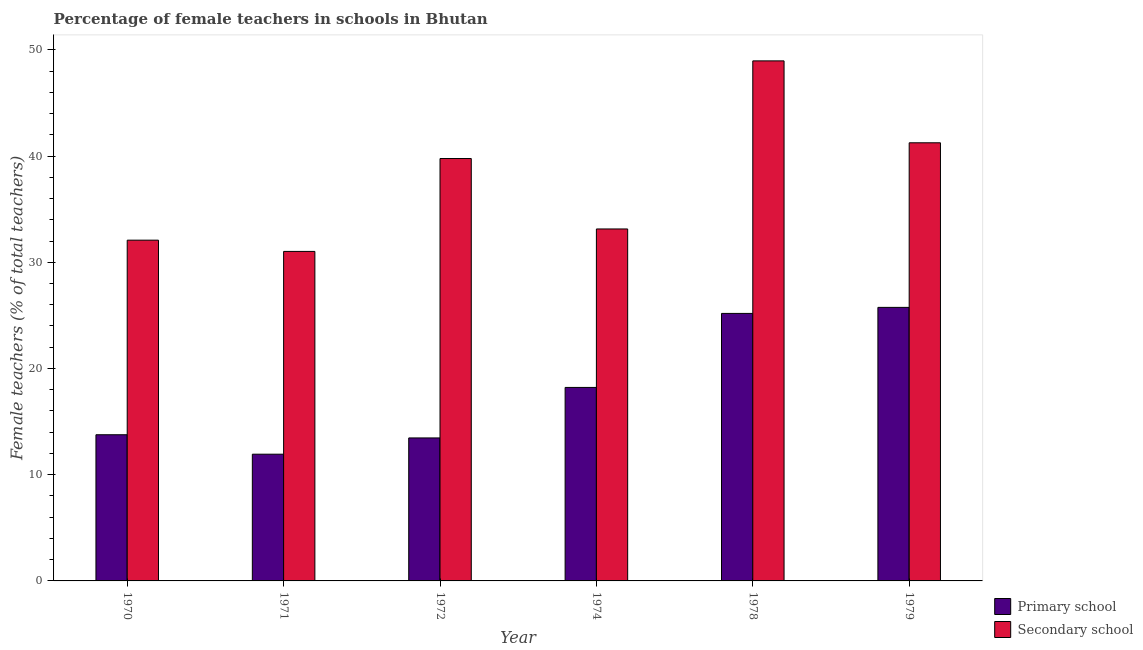How many groups of bars are there?
Ensure brevity in your answer.  6. Are the number of bars per tick equal to the number of legend labels?
Make the answer very short. Yes. Are the number of bars on each tick of the X-axis equal?
Keep it short and to the point. Yes. How many bars are there on the 2nd tick from the right?
Your answer should be compact. 2. What is the label of the 5th group of bars from the left?
Provide a short and direct response. 1978. In how many cases, is the number of bars for a given year not equal to the number of legend labels?
Provide a short and direct response. 0. What is the percentage of female teachers in primary schools in 1974?
Your answer should be very brief. 18.22. Across all years, what is the maximum percentage of female teachers in primary schools?
Your answer should be compact. 25.75. Across all years, what is the minimum percentage of female teachers in primary schools?
Keep it short and to the point. 11.93. In which year was the percentage of female teachers in primary schools maximum?
Your response must be concise. 1979. In which year was the percentage of female teachers in primary schools minimum?
Your answer should be compact. 1971. What is the total percentage of female teachers in primary schools in the graph?
Make the answer very short. 108.31. What is the difference between the percentage of female teachers in secondary schools in 1971 and that in 1978?
Give a very brief answer. -17.94. What is the difference between the percentage of female teachers in primary schools in 1972 and the percentage of female teachers in secondary schools in 1979?
Make the answer very short. -12.29. What is the average percentage of female teachers in primary schools per year?
Provide a succinct answer. 18.05. In the year 1972, what is the difference between the percentage of female teachers in primary schools and percentage of female teachers in secondary schools?
Provide a short and direct response. 0. In how many years, is the percentage of female teachers in secondary schools greater than 44 %?
Offer a terse response. 1. What is the ratio of the percentage of female teachers in primary schools in 1970 to that in 1979?
Your answer should be compact. 0.53. Is the difference between the percentage of female teachers in secondary schools in 1970 and 1972 greater than the difference between the percentage of female teachers in primary schools in 1970 and 1972?
Make the answer very short. No. What is the difference between the highest and the second highest percentage of female teachers in secondary schools?
Offer a very short reply. 7.71. What is the difference between the highest and the lowest percentage of female teachers in secondary schools?
Your answer should be very brief. 17.94. In how many years, is the percentage of female teachers in primary schools greater than the average percentage of female teachers in primary schools taken over all years?
Offer a terse response. 3. What does the 2nd bar from the left in 1978 represents?
Your answer should be compact. Secondary school. What does the 1st bar from the right in 1979 represents?
Offer a very short reply. Secondary school. What is the difference between two consecutive major ticks on the Y-axis?
Provide a succinct answer. 10. Are the values on the major ticks of Y-axis written in scientific E-notation?
Offer a terse response. No. Does the graph contain grids?
Ensure brevity in your answer.  No. What is the title of the graph?
Your response must be concise. Percentage of female teachers in schools in Bhutan. Does "Forest" appear as one of the legend labels in the graph?
Make the answer very short. No. What is the label or title of the X-axis?
Provide a short and direct response. Year. What is the label or title of the Y-axis?
Ensure brevity in your answer.  Female teachers (% of total teachers). What is the Female teachers (% of total teachers) of Primary school in 1970?
Give a very brief answer. 13.76. What is the Female teachers (% of total teachers) in Secondary school in 1970?
Keep it short and to the point. 32.08. What is the Female teachers (% of total teachers) in Primary school in 1971?
Offer a terse response. 11.93. What is the Female teachers (% of total teachers) in Secondary school in 1971?
Your answer should be compact. 31.02. What is the Female teachers (% of total teachers) of Primary school in 1972?
Your response must be concise. 13.46. What is the Female teachers (% of total teachers) of Secondary school in 1972?
Provide a short and direct response. 39.77. What is the Female teachers (% of total teachers) of Primary school in 1974?
Your answer should be very brief. 18.22. What is the Female teachers (% of total teachers) in Secondary school in 1974?
Offer a terse response. 33.14. What is the Female teachers (% of total teachers) in Primary school in 1978?
Your answer should be very brief. 25.18. What is the Female teachers (% of total teachers) in Secondary school in 1978?
Your answer should be very brief. 48.96. What is the Female teachers (% of total teachers) in Primary school in 1979?
Your response must be concise. 25.75. What is the Female teachers (% of total teachers) in Secondary school in 1979?
Provide a succinct answer. 41.25. Across all years, what is the maximum Female teachers (% of total teachers) of Primary school?
Provide a succinct answer. 25.75. Across all years, what is the maximum Female teachers (% of total teachers) of Secondary school?
Your answer should be compact. 48.96. Across all years, what is the minimum Female teachers (% of total teachers) in Primary school?
Ensure brevity in your answer.  11.93. Across all years, what is the minimum Female teachers (% of total teachers) in Secondary school?
Keep it short and to the point. 31.02. What is the total Female teachers (% of total teachers) of Primary school in the graph?
Your response must be concise. 108.31. What is the total Female teachers (% of total teachers) in Secondary school in the graph?
Your answer should be very brief. 226.21. What is the difference between the Female teachers (% of total teachers) in Primary school in 1970 and that in 1971?
Provide a succinct answer. 1.83. What is the difference between the Female teachers (% of total teachers) of Secondary school in 1970 and that in 1971?
Your response must be concise. 1.06. What is the difference between the Female teachers (% of total teachers) of Primary school in 1970 and that in 1972?
Your answer should be very brief. 0.3. What is the difference between the Female teachers (% of total teachers) in Secondary school in 1970 and that in 1972?
Your response must be concise. -7.69. What is the difference between the Female teachers (% of total teachers) of Primary school in 1970 and that in 1974?
Provide a succinct answer. -4.45. What is the difference between the Female teachers (% of total teachers) of Secondary school in 1970 and that in 1974?
Keep it short and to the point. -1.05. What is the difference between the Female teachers (% of total teachers) of Primary school in 1970 and that in 1978?
Make the answer very short. -11.42. What is the difference between the Female teachers (% of total teachers) of Secondary school in 1970 and that in 1978?
Give a very brief answer. -16.88. What is the difference between the Female teachers (% of total teachers) in Primary school in 1970 and that in 1979?
Your response must be concise. -11.99. What is the difference between the Female teachers (% of total teachers) in Secondary school in 1970 and that in 1979?
Give a very brief answer. -9.17. What is the difference between the Female teachers (% of total teachers) of Primary school in 1971 and that in 1972?
Offer a very short reply. -1.53. What is the difference between the Female teachers (% of total teachers) of Secondary school in 1971 and that in 1972?
Keep it short and to the point. -8.75. What is the difference between the Female teachers (% of total teachers) of Primary school in 1971 and that in 1974?
Your response must be concise. -6.29. What is the difference between the Female teachers (% of total teachers) of Secondary school in 1971 and that in 1974?
Your response must be concise. -2.12. What is the difference between the Female teachers (% of total teachers) in Primary school in 1971 and that in 1978?
Provide a short and direct response. -13.25. What is the difference between the Female teachers (% of total teachers) of Secondary school in 1971 and that in 1978?
Provide a short and direct response. -17.94. What is the difference between the Female teachers (% of total teachers) in Primary school in 1971 and that in 1979?
Your answer should be very brief. -13.82. What is the difference between the Female teachers (% of total teachers) of Secondary school in 1971 and that in 1979?
Give a very brief answer. -10.23. What is the difference between the Female teachers (% of total teachers) of Primary school in 1972 and that in 1974?
Ensure brevity in your answer.  -4.75. What is the difference between the Female teachers (% of total teachers) in Secondary school in 1972 and that in 1974?
Make the answer very short. 6.63. What is the difference between the Female teachers (% of total teachers) in Primary school in 1972 and that in 1978?
Offer a terse response. -11.72. What is the difference between the Female teachers (% of total teachers) in Secondary school in 1972 and that in 1978?
Give a very brief answer. -9.19. What is the difference between the Female teachers (% of total teachers) in Primary school in 1972 and that in 1979?
Ensure brevity in your answer.  -12.29. What is the difference between the Female teachers (% of total teachers) in Secondary school in 1972 and that in 1979?
Your response must be concise. -1.48. What is the difference between the Female teachers (% of total teachers) in Primary school in 1974 and that in 1978?
Give a very brief answer. -6.97. What is the difference between the Female teachers (% of total teachers) of Secondary school in 1974 and that in 1978?
Your answer should be compact. -15.82. What is the difference between the Female teachers (% of total teachers) of Primary school in 1974 and that in 1979?
Offer a very short reply. -7.54. What is the difference between the Female teachers (% of total teachers) of Secondary school in 1974 and that in 1979?
Make the answer very short. -8.11. What is the difference between the Female teachers (% of total teachers) in Primary school in 1978 and that in 1979?
Provide a short and direct response. -0.57. What is the difference between the Female teachers (% of total teachers) of Secondary school in 1978 and that in 1979?
Offer a very short reply. 7.71. What is the difference between the Female teachers (% of total teachers) of Primary school in 1970 and the Female teachers (% of total teachers) of Secondary school in 1971?
Offer a very short reply. -17.26. What is the difference between the Female teachers (% of total teachers) in Primary school in 1970 and the Female teachers (% of total teachers) in Secondary school in 1972?
Provide a short and direct response. -26.01. What is the difference between the Female teachers (% of total teachers) in Primary school in 1970 and the Female teachers (% of total teachers) in Secondary school in 1974?
Provide a short and direct response. -19.37. What is the difference between the Female teachers (% of total teachers) in Primary school in 1970 and the Female teachers (% of total teachers) in Secondary school in 1978?
Your answer should be very brief. -35.2. What is the difference between the Female teachers (% of total teachers) in Primary school in 1970 and the Female teachers (% of total teachers) in Secondary school in 1979?
Offer a very short reply. -27.49. What is the difference between the Female teachers (% of total teachers) of Primary school in 1971 and the Female teachers (% of total teachers) of Secondary school in 1972?
Your response must be concise. -27.84. What is the difference between the Female teachers (% of total teachers) of Primary school in 1971 and the Female teachers (% of total teachers) of Secondary school in 1974?
Keep it short and to the point. -21.21. What is the difference between the Female teachers (% of total teachers) in Primary school in 1971 and the Female teachers (% of total teachers) in Secondary school in 1978?
Offer a very short reply. -37.03. What is the difference between the Female teachers (% of total teachers) in Primary school in 1971 and the Female teachers (% of total teachers) in Secondary school in 1979?
Ensure brevity in your answer.  -29.32. What is the difference between the Female teachers (% of total teachers) of Primary school in 1972 and the Female teachers (% of total teachers) of Secondary school in 1974?
Your answer should be very brief. -19.67. What is the difference between the Female teachers (% of total teachers) of Primary school in 1972 and the Female teachers (% of total teachers) of Secondary school in 1978?
Give a very brief answer. -35.5. What is the difference between the Female teachers (% of total teachers) of Primary school in 1972 and the Female teachers (% of total teachers) of Secondary school in 1979?
Offer a very short reply. -27.79. What is the difference between the Female teachers (% of total teachers) of Primary school in 1974 and the Female teachers (% of total teachers) of Secondary school in 1978?
Provide a succinct answer. -30.74. What is the difference between the Female teachers (% of total teachers) in Primary school in 1974 and the Female teachers (% of total teachers) in Secondary school in 1979?
Offer a terse response. -23.03. What is the difference between the Female teachers (% of total teachers) in Primary school in 1978 and the Female teachers (% of total teachers) in Secondary school in 1979?
Keep it short and to the point. -16.06. What is the average Female teachers (% of total teachers) in Primary school per year?
Your answer should be compact. 18.05. What is the average Female teachers (% of total teachers) of Secondary school per year?
Make the answer very short. 37.7. In the year 1970, what is the difference between the Female teachers (% of total teachers) of Primary school and Female teachers (% of total teachers) of Secondary school?
Offer a very short reply. -18.32. In the year 1971, what is the difference between the Female teachers (% of total teachers) in Primary school and Female teachers (% of total teachers) in Secondary school?
Your response must be concise. -19.09. In the year 1972, what is the difference between the Female teachers (% of total teachers) of Primary school and Female teachers (% of total teachers) of Secondary school?
Your answer should be very brief. -26.31. In the year 1974, what is the difference between the Female teachers (% of total teachers) in Primary school and Female teachers (% of total teachers) in Secondary school?
Ensure brevity in your answer.  -14.92. In the year 1978, what is the difference between the Female teachers (% of total teachers) of Primary school and Female teachers (% of total teachers) of Secondary school?
Provide a short and direct response. -23.78. In the year 1979, what is the difference between the Female teachers (% of total teachers) of Primary school and Female teachers (% of total teachers) of Secondary school?
Offer a terse response. -15.5. What is the ratio of the Female teachers (% of total teachers) of Primary school in 1970 to that in 1971?
Provide a short and direct response. 1.15. What is the ratio of the Female teachers (% of total teachers) in Secondary school in 1970 to that in 1971?
Your answer should be very brief. 1.03. What is the ratio of the Female teachers (% of total teachers) of Primary school in 1970 to that in 1972?
Provide a short and direct response. 1.02. What is the ratio of the Female teachers (% of total teachers) of Secondary school in 1970 to that in 1972?
Provide a short and direct response. 0.81. What is the ratio of the Female teachers (% of total teachers) in Primary school in 1970 to that in 1974?
Ensure brevity in your answer.  0.76. What is the ratio of the Female teachers (% of total teachers) in Secondary school in 1970 to that in 1974?
Offer a very short reply. 0.97. What is the ratio of the Female teachers (% of total teachers) of Primary school in 1970 to that in 1978?
Give a very brief answer. 0.55. What is the ratio of the Female teachers (% of total teachers) in Secondary school in 1970 to that in 1978?
Provide a succinct answer. 0.66. What is the ratio of the Female teachers (% of total teachers) of Primary school in 1970 to that in 1979?
Provide a succinct answer. 0.53. What is the ratio of the Female teachers (% of total teachers) in Primary school in 1971 to that in 1972?
Offer a very short reply. 0.89. What is the ratio of the Female teachers (% of total teachers) of Secondary school in 1971 to that in 1972?
Offer a very short reply. 0.78. What is the ratio of the Female teachers (% of total teachers) in Primary school in 1971 to that in 1974?
Your answer should be very brief. 0.66. What is the ratio of the Female teachers (% of total teachers) of Secondary school in 1971 to that in 1974?
Your response must be concise. 0.94. What is the ratio of the Female teachers (% of total teachers) of Primary school in 1971 to that in 1978?
Your answer should be very brief. 0.47. What is the ratio of the Female teachers (% of total teachers) in Secondary school in 1971 to that in 1978?
Keep it short and to the point. 0.63. What is the ratio of the Female teachers (% of total teachers) of Primary school in 1971 to that in 1979?
Ensure brevity in your answer.  0.46. What is the ratio of the Female teachers (% of total teachers) in Secondary school in 1971 to that in 1979?
Offer a terse response. 0.75. What is the ratio of the Female teachers (% of total teachers) of Primary school in 1972 to that in 1974?
Provide a succinct answer. 0.74. What is the ratio of the Female teachers (% of total teachers) of Secondary school in 1972 to that in 1974?
Keep it short and to the point. 1.2. What is the ratio of the Female teachers (% of total teachers) in Primary school in 1972 to that in 1978?
Your answer should be very brief. 0.53. What is the ratio of the Female teachers (% of total teachers) of Secondary school in 1972 to that in 1978?
Give a very brief answer. 0.81. What is the ratio of the Female teachers (% of total teachers) of Primary school in 1972 to that in 1979?
Ensure brevity in your answer.  0.52. What is the ratio of the Female teachers (% of total teachers) in Secondary school in 1972 to that in 1979?
Ensure brevity in your answer.  0.96. What is the ratio of the Female teachers (% of total teachers) of Primary school in 1974 to that in 1978?
Ensure brevity in your answer.  0.72. What is the ratio of the Female teachers (% of total teachers) of Secondary school in 1974 to that in 1978?
Provide a succinct answer. 0.68. What is the ratio of the Female teachers (% of total teachers) of Primary school in 1974 to that in 1979?
Your answer should be compact. 0.71. What is the ratio of the Female teachers (% of total teachers) in Secondary school in 1974 to that in 1979?
Make the answer very short. 0.8. What is the ratio of the Female teachers (% of total teachers) of Primary school in 1978 to that in 1979?
Give a very brief answer. 0.98. What is the ratio of the Female teachers (% of total teachers) in Secondary school in 1978 to that in 1979?
Keep it short and to the point. 1.19. What is the difference between the highest and the second highest Female teachers (% of total teachers) in Primary school?
Offer a terse response. 0.57. What is the difference between the highest and the second highest Female teachers (% of total teachers) of Secondary school?
Keep it short and to the point. 7.71. What is the difference between the highest and the lowest Female teachers (% of total teachers) of Primary school?
Offer a very short reply. 13.82. What is the difference between the highest and the lowest Female teachers (% of total teachers) of Secondary school?
Ensure brevity in your answer.  17.94. 